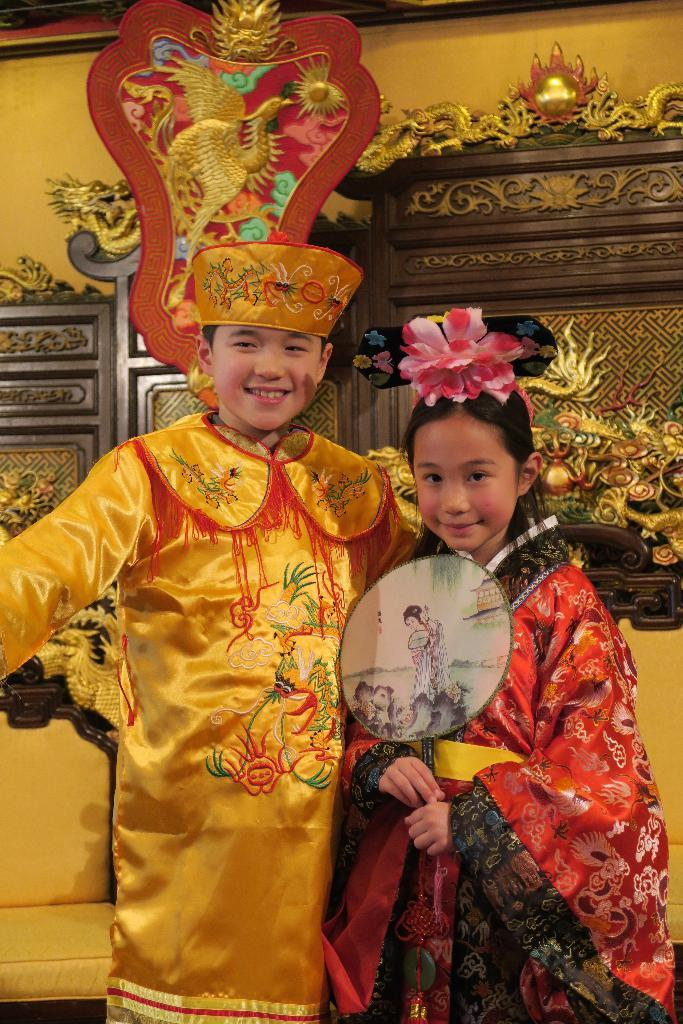How many kids are present in the image? There are two kids in the image. What are the kids wearing? The kids are wearing traditional dress. What can be seen behind the kids? There are chairs behind the kids. What is the background of the image like? There is a decorative wall in the background. What type of pollution can be seen in the image? There is no pollution visible in the image. Is there a scarf being used as a prop in the image? There is no scarf present in the image. 